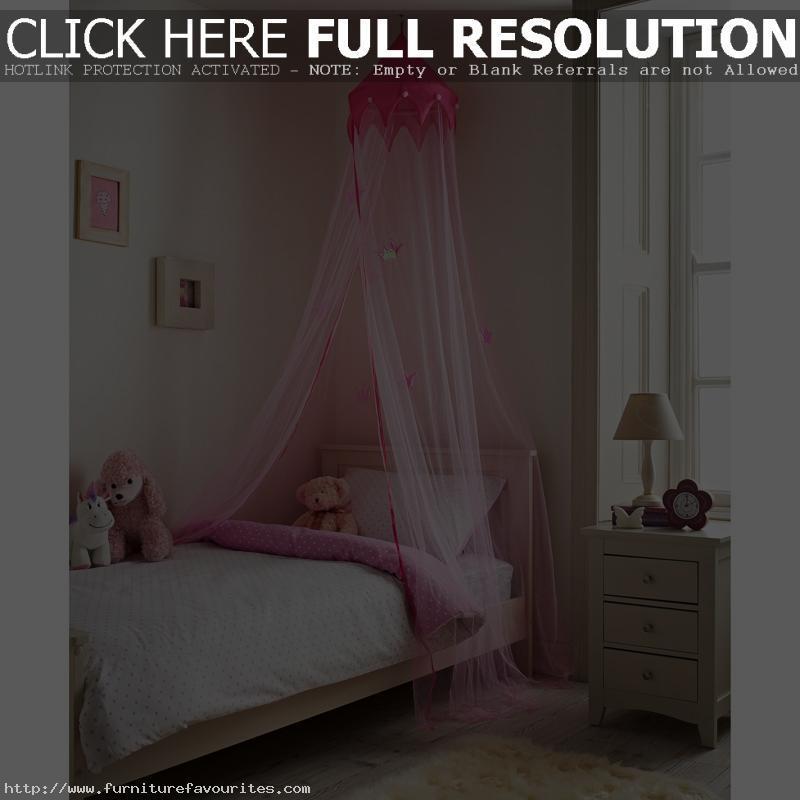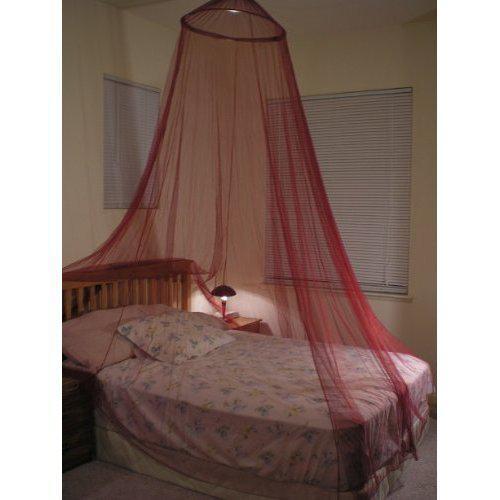The first image is the image on the left, the second image is the image on the right. For the images shown, is this caption "All curtains displayed are pink or red and hung from a circular shaped rod directly above the bed." true? Answer yes or no. Yes. The first image is the image on the left, the second image is the image on the right. Given the left and right images, does the statement "The left bed is covered by a square drape, the right bed by a round drape." hold true? Answer yes or no. No. 